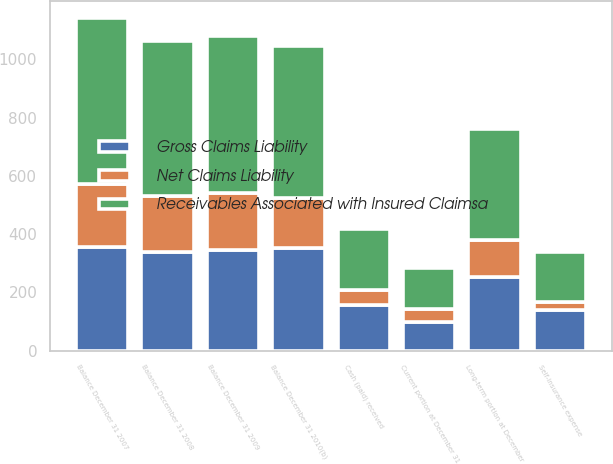Convert chart. <chart><loc_0><loc_0><loc_500><loc_500><stacked_bar_chart><ecel><fcel>Balance December 31 2007<fcel>Self-insurance expense<fcel>Cash (paid) received<fcel>Balance December 31 2008<fcel>Balance December 31 2009<fcel>Balance December 31 2010(b)<fcel>Current portion at December 31<fcel>Long-term portion at December<nl><fcel>Receivables Associated with Insured Claimsa<fcel>571<fcel>169<fcel>209<fcel>531<fcel>541<fcel>523<fcel>142<fcel>381<nl><fcel>Net Claims Liability<fcel>214<fcel>28<fcel>51<fcel>191<fcel>194<fcel>170<fcel>43<fcel>127<nl><fcel>Gross Claims Liability<fcel>357<fcel>141<fcel>158<fcel>340<fcel>347<fcel>353<fcel>99<fcel>254<nl></chart> 